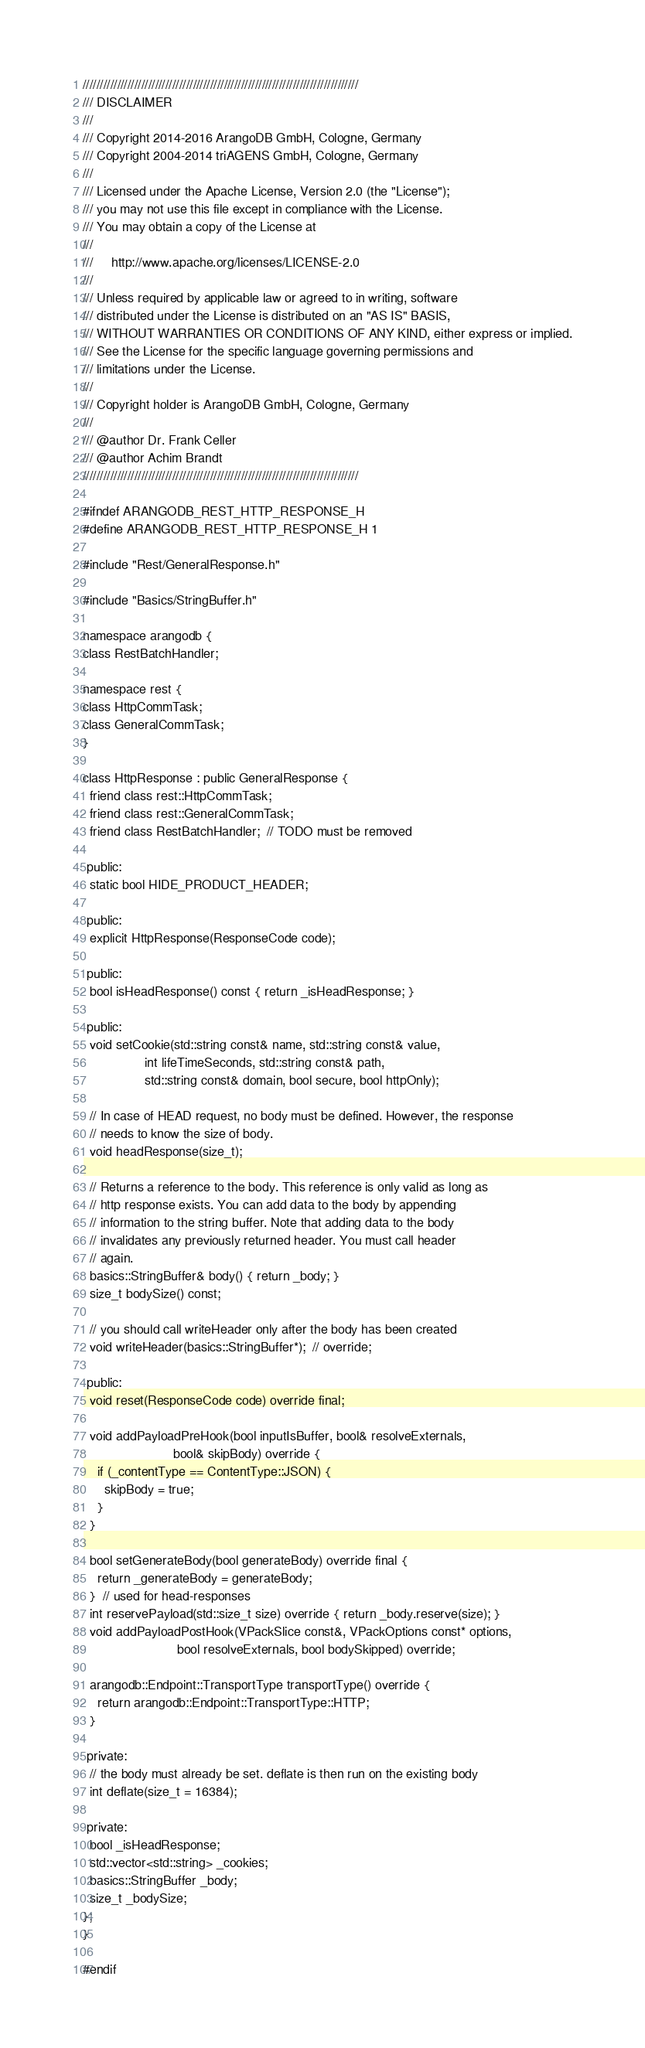<code> <loc_0><loc_0><loc_500><loc_500><_C_>////////////////////////////////////////////////////////////////////////////////
/// DISCLAIMER
///
/// Copyright 2014-2016 ArangoDB GmbH, Cologne, Germany
/// Copyright 2004-2014 triAGENS GmbH, Cologne, Germany
///
/// Licensed under the Apache License, Version 2.0 (the "License");
/// you may not use this file except in compliance with the License.
/// You may obtain a copy of the License at
///
///     http://www.apache.org/licenses/LICENSE-2.0
///
/// Unless required by applicable law or agreed to in writing, software
/// distributed under the License is distributed on an "AS IS" BASIS,
/// WITHOUT WARRANTIES OR CONDITIONS OF ANY KIND, either express or implied.
/// See the License for the specific language governing permissions and
/// limitations under the License.
///
/// Copyright holder is ArangoDB GmbH, Cologne, Germany
///
/// @author Dr. Frank Celler
/// @author Achim Brandt
////////////////////////////////////////////////////////////////////////////////

#ifndef ARANGODB_REST_HTTP_RESPONSE_H
#define ARANGODB_REST_HTTP_RESPONSE_H 1

#include "Rest/GeneralResponse.h"

#include "Basics/StringBuffer.h"

namespace arangodb {
class RestBatchHandler;

namespace rest {
class HttpCommTask;
class GeneralCommTask;
}

class HttpResponse : public GeneralResponse {
  friend class rest::HttpCommTask;
  friend class rest::GeneralCommTask;
  friend class RestBatchHandler;  // TODO must be removed

 public:
  static bool HIDE_PRODUCT_HEADER;

 public:
  explicit HttpResponse(ResponseCode code);

 public:
  bool isHeadResponse() const { return _isHeadResponse; }

 public:
  void setCookie(std::string const& name, std::string const& value,
                 int lifeTimeSeconds, std::string const& path,
                 std::string const& domain, bool secure, bool httpOnly);

  // In case of HEAD request, no body must be defined. However, the response
  // needs to know the size of body.
  void headResponse(size_t);

  // Returns a reference to the body. This reference is only valid as long as
  // http response exists. You can add data to the body by appending
  // information to the string buffer. Note that adding data to the body
  // invalidates any previously returned header. You must call header
  // again.
  basics::StringBuffer& body() { return _body; }
  size_t bodySize() const;

  // you should call writeHeader only after the body has been created
  void writeHeader(basics::StringBuffer*);  // override;

 public:
  void reset(ResponseCode code) override final;

  void addPayloadPreHook(bool inputIsBuffer, bool& resolveExternals,
                         bool& skipBody) override {
    if (_contentType == ContentType::JSON) {
      skipBody = true;
    }
  }

  bool setGenerateBody(bool generateBody) override final {
    return _generateBody = generateBody;
  }  // used for head-responses
  int reservePayload(std::size_t size) override { return _body.reserve(size); }
  void addPayloadPostHook(VPackSlice const&, VPackOptions const* options,
                          bool resolveExternals, bool bodySkipped) override;

  arangodb::Endpoint::TransportType transportType() override {
    return arangodb::Endpoint::TransportType::HTTP;
  }

 private:
  // the body must already be set. deflate is then run on the existing body
  int deflate(size_t = 16384);

 private:
  bool _isHeadResponse;
  std::vector<std::string> _cookies;
  basics::StringBuffer _body;
  size_t _bodySize;
};
}

#endif
</code> 